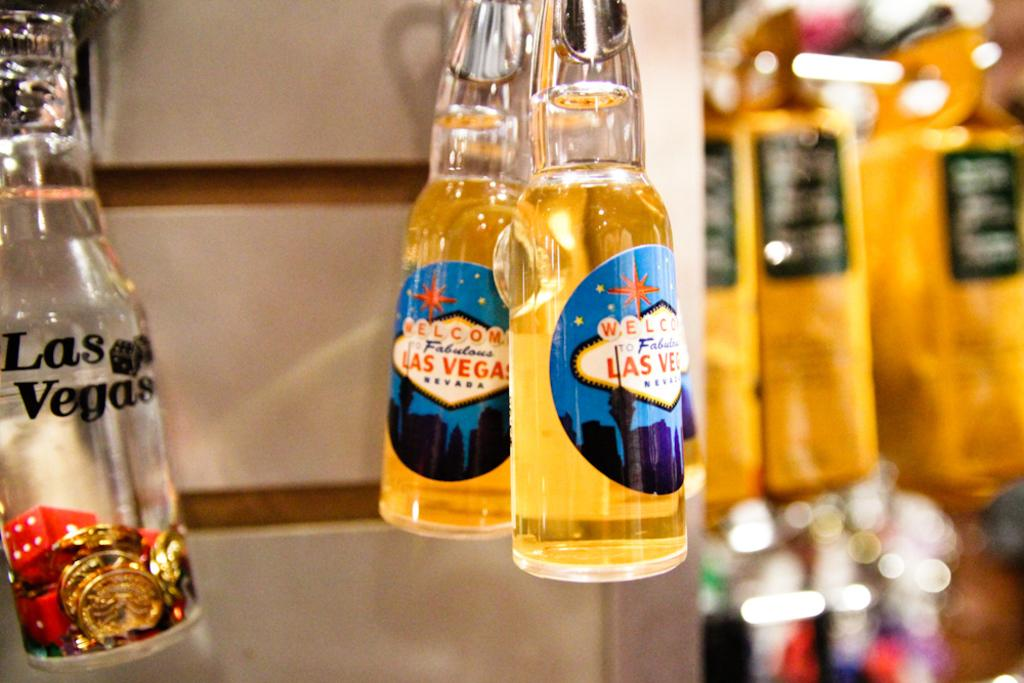Provide a one-sentence caption for the provided image. Several bottles with the words Las Vegas on them. 